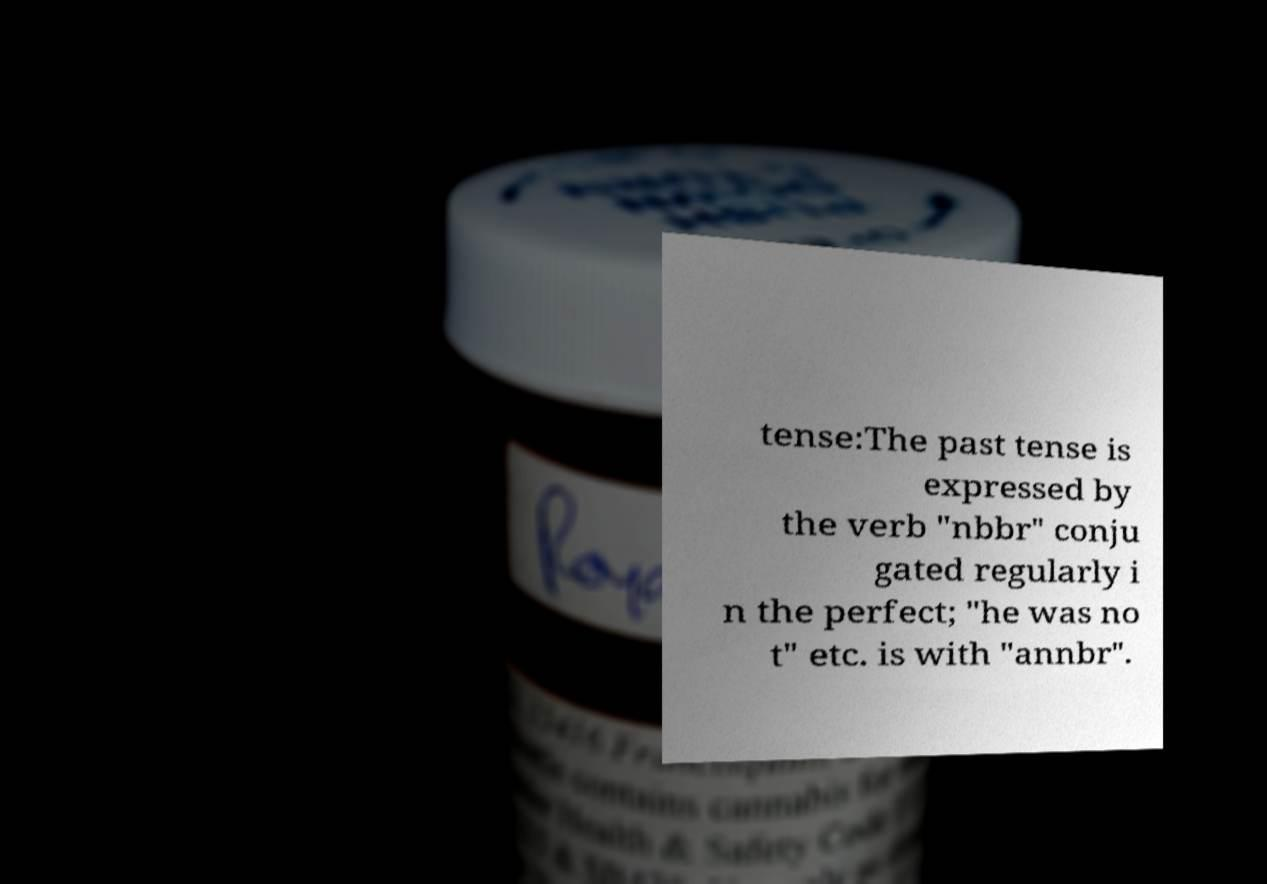Can you read and provide the text displayed in the image?This photo seems to have some interesting text. Can you extract and type it out for me? tense:The past tense is expressed by the verb "nbbr" conju gated regularly i n the perfect; "he was no t" etc. is with "annbr". 